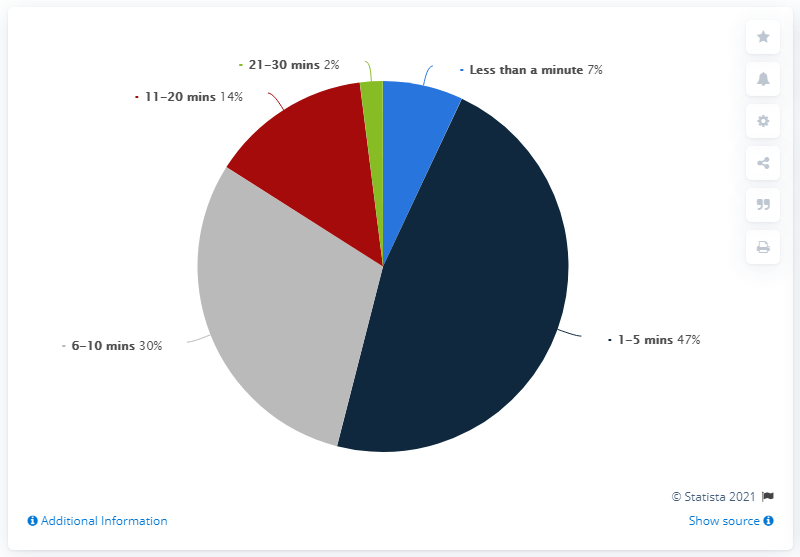Highlight a few significant elements in this photo. Seven people waited for less than a minute. A total of 77 individuals waited within a time range of 1 to 10 minutes. 